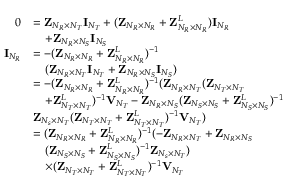Convert formula to latex. <formula><loc_0><loc_0><loc_500><loc_500>\begin{array} { r l } { 0 } & { = { Z } _ { N _ { R } \times N _ { T } } { I } _ { N _ { T } } + ( { Z } _ { N _ { R } \times N _ { R } } + { Z } _ { N _ { R } \times N _ { R } } ^ { L } ) { I } _ { N _ { R } } } \\ & { \quad + { Z } _ { N _ { R } \times N _ { S } } { I } _ { N _ { S } } } \\ { { I } _ { N _ { R } } } & { = - ( { Z } _ { N _ { R } \times N _ { R } } + { Z } _ { N _ { R } \times N _ { R } } ^ { L } ) ^ { - 1 } } \\ & { \quad ( { Z } _ { N _ { R } \times N _ { T } } { I } _ { N _ { T } } + { Z } _ { N _ { R } \times N _ { S } } { I } _ { N _ { S } } ) } \\ & { = - ( { Z } _ { N _ { R } \times N _ { R } } + { Z } _ { N _ { R } \times N _ { R } } ^ { L } ) ^ { - 1 } ( { Z } _ { N _ { R } \times N _ { T } } ( { Z } _ { N _ { T } \times N _ { T } } } \\ & { \quad + { Z } _ { N _ { T } \times N _ { T } } ^ { L } ) ^ { - 1 } { V } _ { N _ { T } } - { Z } _ { N _ { R } \times N _ { S } } ( { Z } _ { N _ { S } \times N _ { S } } + { Z } _ { N _ { S } \times N _ { S } } ^ { L } ) ^ { - 1 } } \\ & { { Z } _ { N _ { s } \times N _ { T } } ( { Z } _ { N _ { T } \times N _ { T } } + { Z } _ { N _ { T } \times N _ { T } } ^ { L } ) ^ { - 1 } { V } _ { N _ { T } } ) } \\ & { = ( { Z } _ { N _ { R } \times N _ { R } } + { Z } _ { N _ { R } \times N _ { R } } ^ { L } ) ^ { - 1 } ( - { Z } _ { N _ { R } \times N _ { T } } + { Z } _ { N _ { R } \times N _ { S } } } \\ & { \quad ( { Z } _ { N _ { S } \times N _ { S } } + { Z } _ { N _ { S } \times N _ { S } } ^ { L } ) ^ { - 1 } { Z } _ { N _ { s } \times N _ { T } } ) } \\ & { \quad \times ( { Z } _ { N _ { T } \times N _ { T } } + { Z } _ { N _ { T } \times N _ { T } } ^ { L } ) ^ { - 1 } { V } _ { N _ { T } } } \end{array}</formula> 